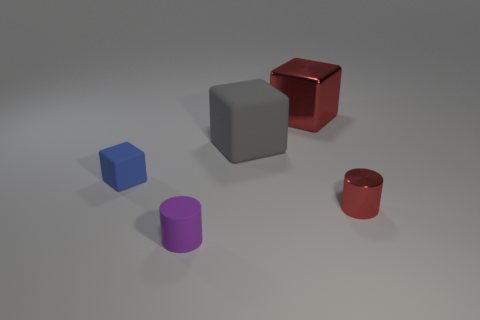Add 4 yellow cylinders. How many objects exist? 9 Subtract all red cubes. How many cubes are left? 2 Subtract all gray blocks. How many blocks are left? 2 Subtract 0 red spheres. How many objects are left? 5 Subtract all blocks. How many objects are left? 2 Subtract 1 cubes. How many cubes are left? 2 Subtract all yellow cylinders. Subtract all red balls. How many cylinders are left? 2 Subtract all yellow cylinders. How many gray cubes are left? 1 Subtract all big cyan rubber spheres. Subtract all gray cubes. How many objects are left? 4 Add 5 red objects. How many red objects are left? 7 